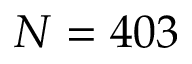<formula> <loc_0><loc_0><loc_500><loc_500>N = 4 0 3</formula> 